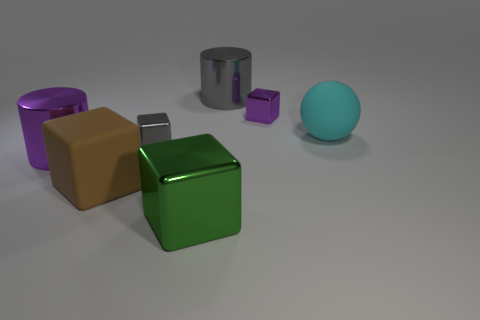Add 2 big cylinders. How many objects exist? 9 Subtract all cylinders. How many objects are left? 5 Add 3 big green shiny objects. How many big green shiny objects exist? 4 Subtract 0 gray spheres. How many objects are left? 7 Subtract all cyan things. Subtract all rubber cubes. How many objects are left? 5 Add 7 brown blocks. How many brown blocks are left? 8 